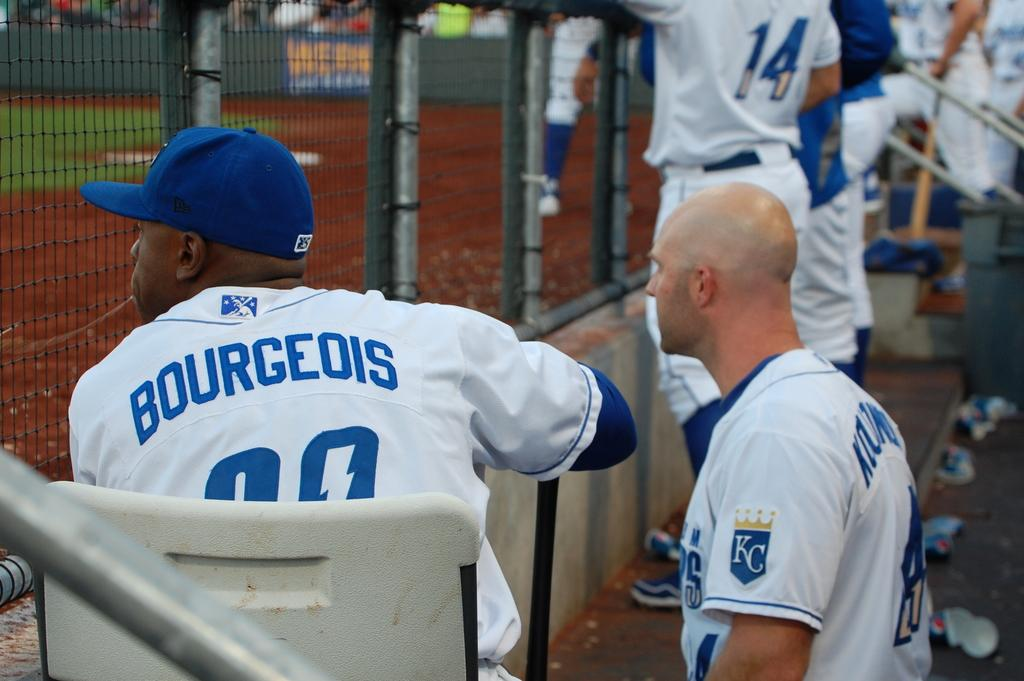<image>
Share a concise interpretation of the image provided. Player Bourgeois watches the game from the Kansas City dugout. 